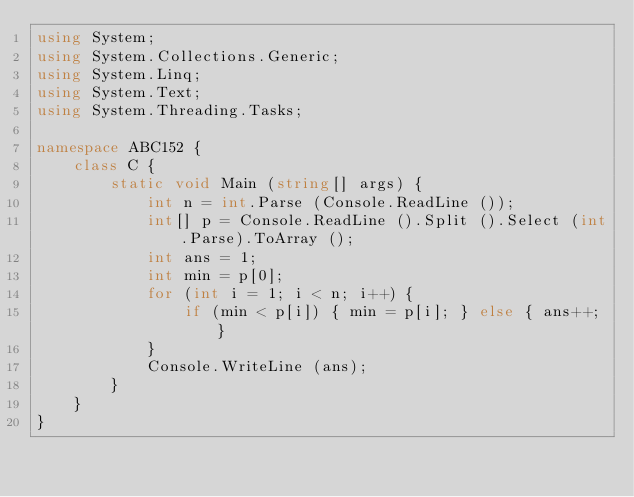Convert code to text. <code><loc_0><loc_0><loc_500><loc_500><_C#_>using System;
using System.Collections.Generic;
using System.Linq;
using System.Text;
using System.Threading.Tasks;

namespace ABC152 {
    class C {
        static void Main (string[] args) {
            int n = int.Parse (Console.ReadLine ());
            int[] p = Console.ReadLine ().Split ().Select (int.Parse).ToArray ();
            int ans = 1;
            int min = p[0];
            for (int i = 1; i < n; i++) {
                if (min < p[i]) { min = p[i]; } else { ans++; }
            }
            Console.WriteLine (ans);
        }
    }
}</code> 